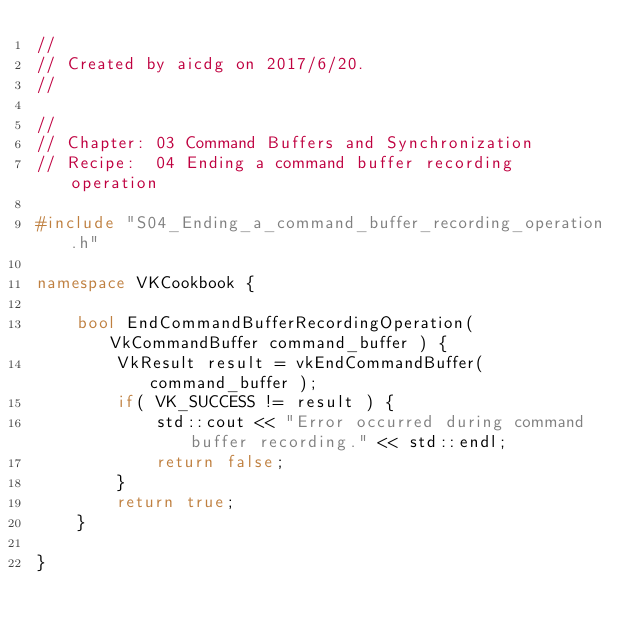<code> <loc_0><loc_0><loc_500><loc_500><_C++_>//
// Created by aicdg on 2017/6/20.
//

//
// Chapter: 03 Command Buffers and Synchronization
// Recipe:  04 Ending a command buffer recording operation

#include "S04_Ending_a_command_buffer_recording_operation.h"

namespace VKCookbook {

    bool EndCommandBufferRecordingOperation( VkCommandBuffer command_buffer ) {
        VkResult result = vkEndCommandBuffer( command_buffer );
        if( VK_SUCCESS != result ) {
            std::cout << "Error occurred during command buffer recording." << std::endl;
            return false;
        }
        return true;
    }

}</code> 